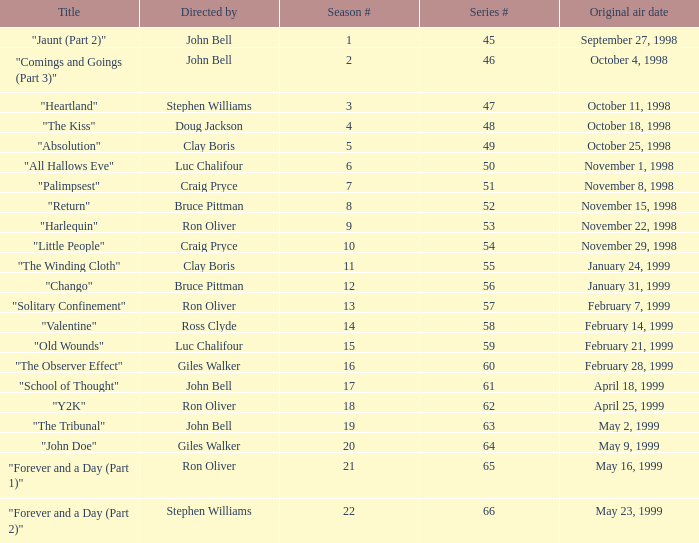Which Original air date has a Season # smaller than 21, and a Title of "palimpsest"? November 8, 1998. 